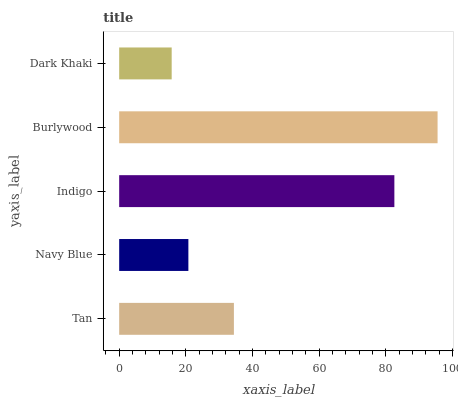Is Dark Khaki the minimum?
Answer yes or no. Yes. Is Burlywood the maximum?
Answer yes or no. Yes. Is Navy Blue the minimum?
Answer yes or no. No. Is Navy Blue the maximum?
Answer yes or no. No. Is Tan greater than Navy Blue?
Answer yes or no. Yes. Is Navy Blue less than Tan?
Answer yes or no. Yes. Is Navy Blue greater than Tan?
Answer yes or no. No. Is Tan less than Navy Blue?
Answer yes or no. No. Is Tan the high median?
Answer yes or no. Yes. Is Tan the low median?
Answer yes or no. Yes. Is Navy Blue the high median?
Answer yes or no. No. Is Burlywood the low median?
Answer yes or no. No. 